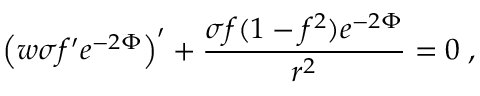Convert formula to latex. <formula><loc_0><loc_0><loc_500><loc_500>\left ( w \sigma f ^ { \prime } e ^ { - 2 \Phi } \right ) ^ { \prime } + \frac { \sigma f ( 1 - f ^ { 2 } ) e ^ { - 2 \Phi } } { r ^ { 2 } } = 0 \, ,</formula> 